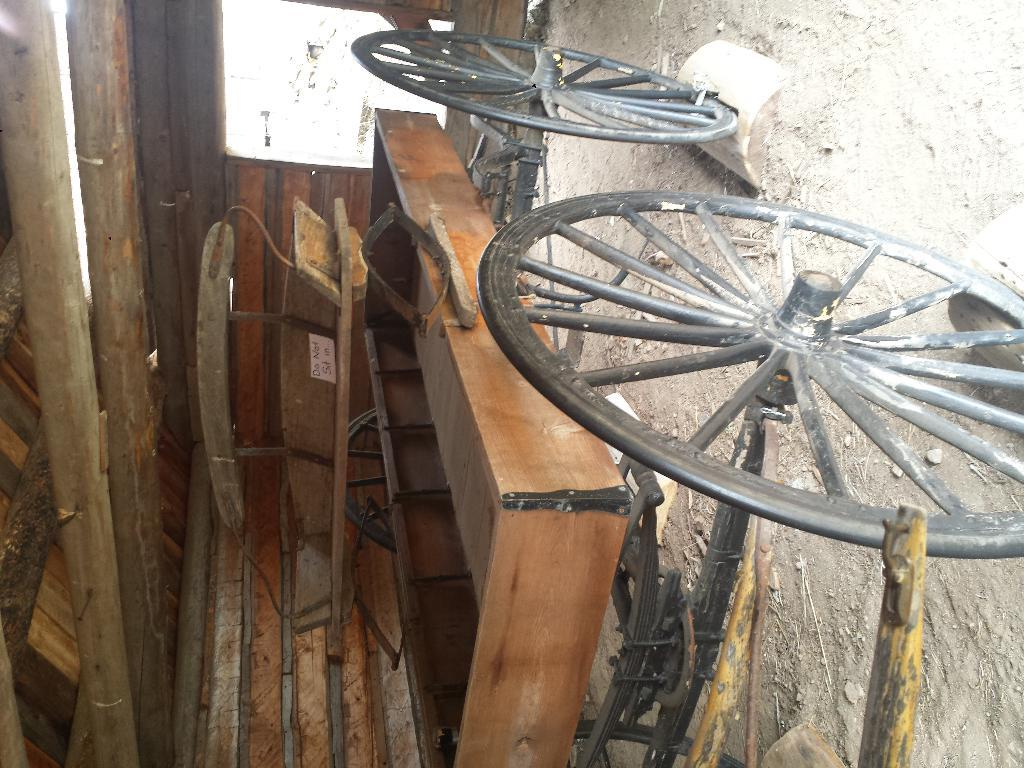What is the main object in the image? There is a wooden tray in the image. What feature is added to the wooden tray? Four wheels are attached to the wooden tray. Where is the wooden tray located? The wooden tray is kept in a wooden shed. What type of string is used to hold the wooden tray together? There is no mention of string being used to hold the wooden tray together in the image. 